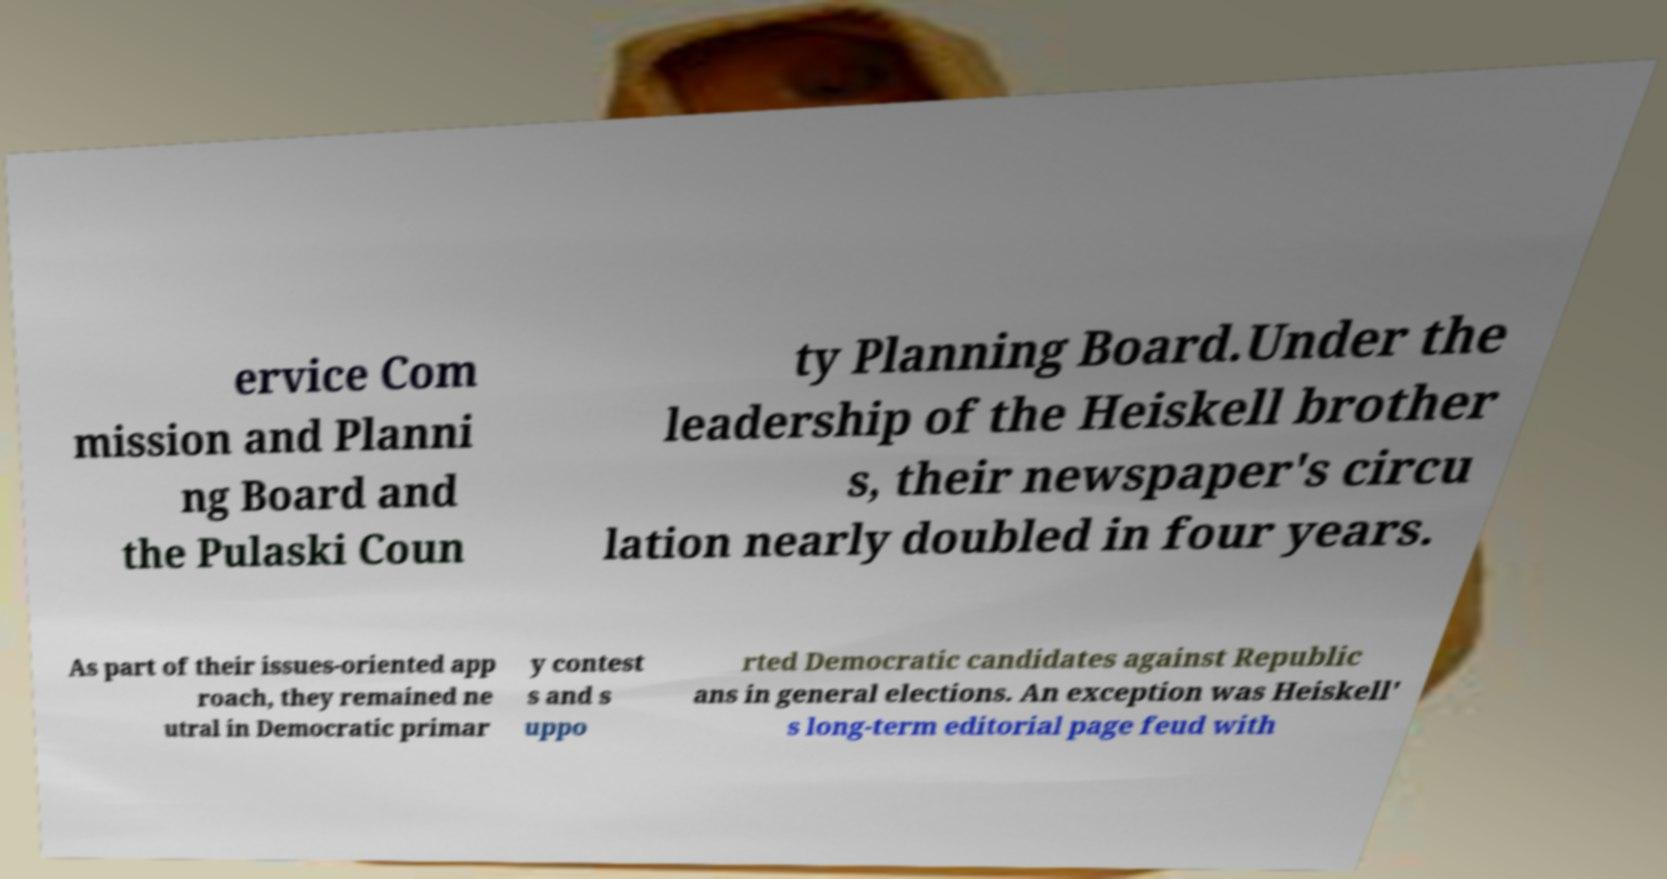Can you accurately transcribe the text from the provided image for me? ervice Com mission and Planni ng Board and the Pulaski Coun ty Planning Board.Under the leadership of the Heiskell brother s, their newspaper's circu lation nearly doubled in four years. As part of their issues-oriented app roach, they remained ne utral in Democratic primar y contest s and s uppo rted Democratic candidates against Republic ans in general elections. An exception was Heiskell' s long-term editorial page feud with 